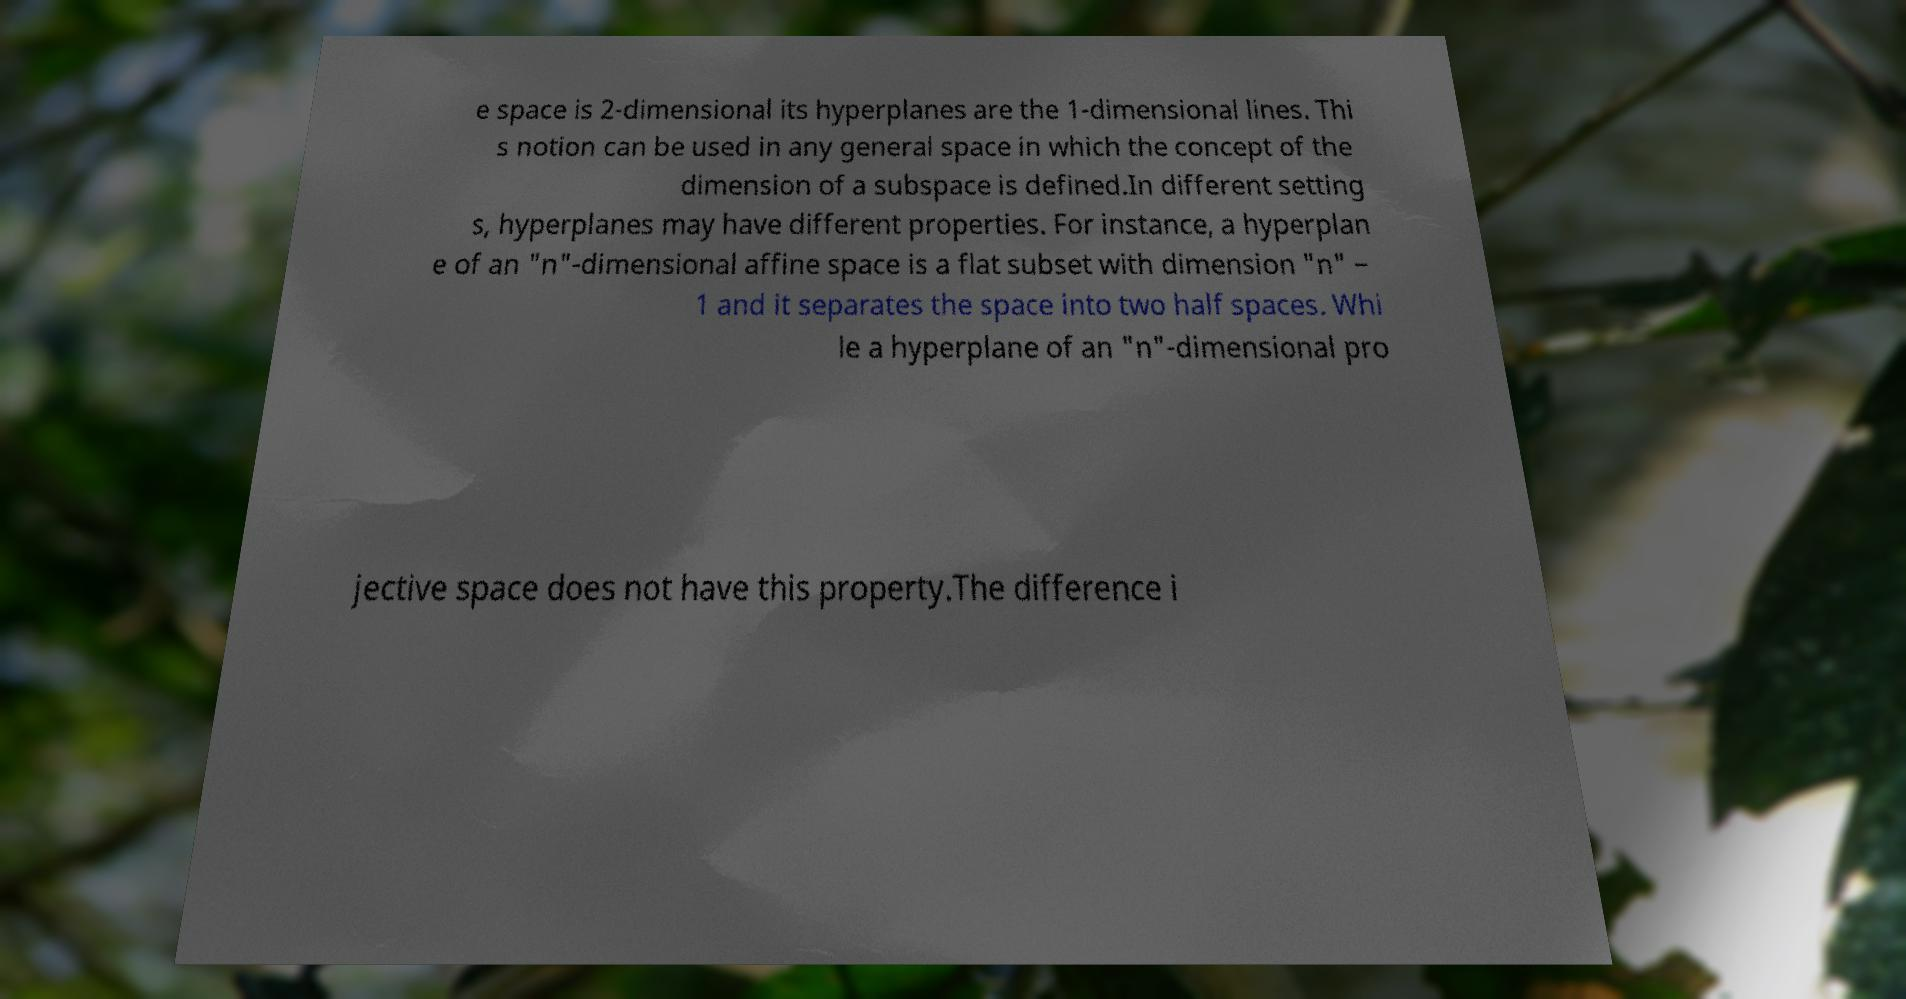Please identify and transcribe the text found in this image. e space is 2-dimensional its hyperplanes are the 1-dimensional lines. Thi s notion can be used in any general space in which the concept of the dimension of a subspace is defined.In different setting s, hyperplanes may have different properties. For instance, a hyperplan e of an "n"-dimensional affine space is a flat subset with dimension "n" − 1 and it separates the space into two half spaces. Whi le a hyperplane of an "n"-dimensional pro jective space does not have this property.The difference i 